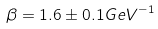<formula> <loc_0><loc_0><loc_500><loc_500>\beta = 1 . 6 \pm 0 . 1 { G e V } ^ { - 1 }</formula> 